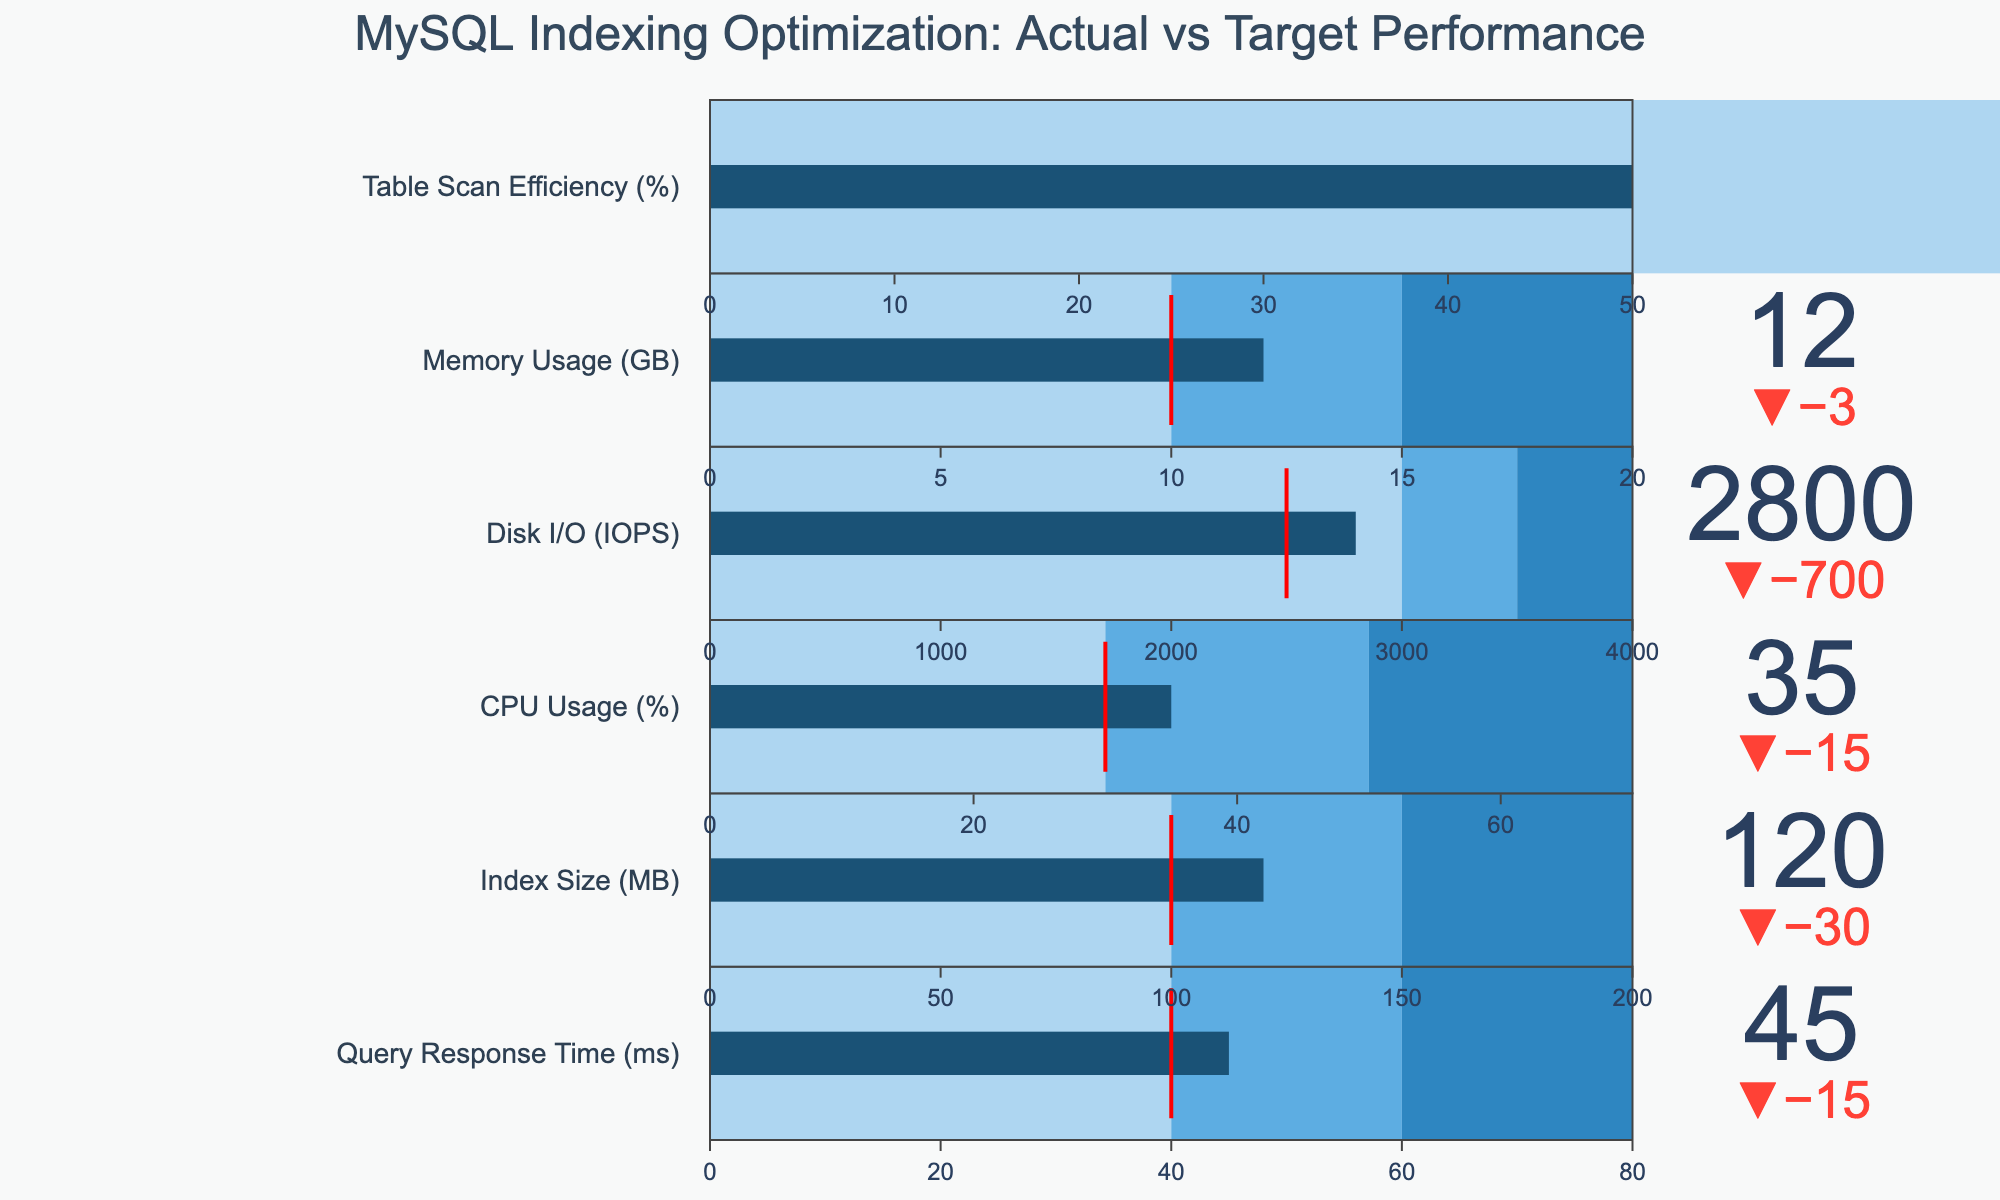What is the title of the figure? The title is usually displayed prominently at the top of the figure. In this case, it reads "MySQL Indexing Optimization: Actual vs Target Performance".
Answer: MySQL Indexing Optimization: Actual vs Target Performance What is the actual value for CPU Usage (%)? The actual value is displayed on the bullet chart for CPU Usage (%). This value is directly written as a number near the bar.
Answer: 35% How does the actual Index Size (MB) compare to the comparative value? Look at the bullet chart for Index Size (MB). Compare the actual value (represented by the length of the bar) to the comparative value indicated beside it.
Answer: The actual Index Size (120 MB) is less than the comparative value (150 MB) Which category has the highest actual value? You need to look at all the actual values for each category and identify the highest one. In this data, Disk I/O (IOPS) shows the highest actual value.
Answer: Disk I/O (IOPS) Is the actual Query Response Time (ms) better or worse than the target? Compare the actual value of Query Response Time (ms) to the target value. If the actual is lower, it is better; if higher, it is worse.
Answer: Worse What is the difference between the actual and target values for Memory Usage (GB)? Subtract the target value from the actual value. For Memory Usage, the target is 10 GB and the actual is 12 GB. So, 12 - 10 = 2.
Answer: 2 GB Which category shows a better-than-comparative performance? Identify categories where the actual value is less than the comparative value. Look at all the relevant charts: Query Response Time, Index Size, CPU Usage, Memory Usage, and Table Scan Efficiency.
Answer: Query Response Time (ms), Index Size (MB), CPU Usage (%), Disk I/O (IOPS) Does any category meet its target value exactly? Check if any category's actual value equals its target value. None of the actual values exactly match their target values.
Answer: No What is the shading color for the worst range in Disk I/O (IOPS)? The worst range is usually represented by the color farthest to the left on the bullet chart. According to the given code, this color is "#AED6F1".
Answer: Light blue (or #AED6F1) Is the CPU Usage (%) within the acceptable range based on the plot's step colors? You need to check where the actual value of 35% falls within the ranges marked by different colors. The value falls within the blue range, where the thresholds are marked by 30% and 50%.
Answer: Yes 